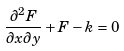Convert formula to latex. <formula><loc_0><loc_0><loc_500><loc_500>\frac { \partial ^ { 2 } F } { \partial x \partial y } + F - k = 0</formula> 